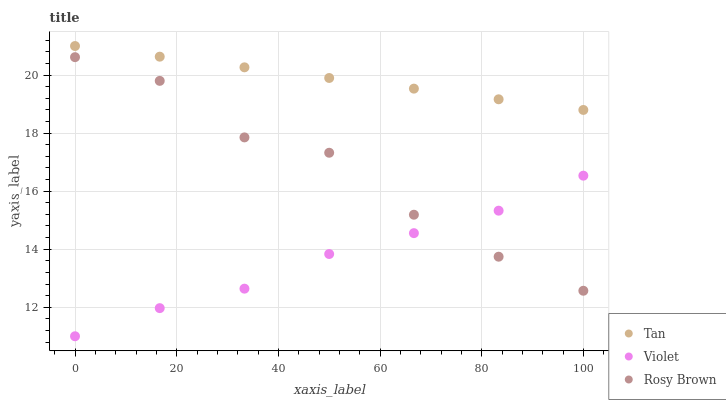Does Violet have the minimum area under the curve?
Answer yes or no. Yes. Does Tan have the maximum area under the curve?
Answer yes or no. Yes. Does Rosy Brown have the minimum area under the curve?
Answer yes or no. No. Does Rosy Brown have the maximum area under the curve?
Answer yes or no. No. Is Tan the smoothest?
Answer yes or no. Yes. Is Rosy Brown the roughest?
Answer yes or no. Yes. Is Violet the smoothest?
Answer yes or no. No. Is Violet the roughest?
Answer yes or no. No. Does Violet have the lowest value?
Answer yes or no. Yes. Does Rosy Brown have the lowest value?
Answer yes or no. No. Does Tan have the highest value?
Answer yes or no. Yes. Does Rosy Brown have the highest value?
Answer yes or no. No. Is Rosy Brown less than Tan?
Answer yes or no. Yes. Is Tan greater than Violet?
Answer yes or no. Yes. Does Violet intersect Rosy Brown?
Answer yes or no. Yes. Is Violet less than Rosy Brown?
Answer yes or no. No. Is Violet greater than Rosy Brown?
Answer yes or no. No. Does Rosy Brown intersect Tan?
Answer yes or no. No. 